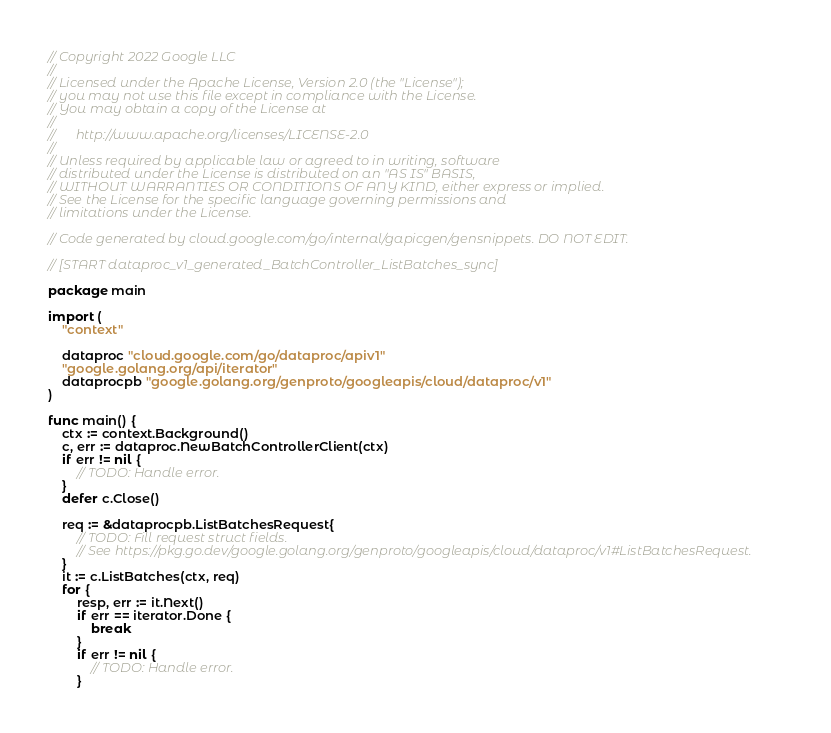<code> <loc_0><loc_0><loc_500><loc_500><_Go_>// Copyright 2022 Google LLC
//
// Licensed under the Apache License, Version 2.0 (the "License");
// you may not use this file except in compliance with the License.
// You may obtain a copy of the License at
//
//      http://www.apache.org/licenses/LICENSE-2.0
//
// Unless required by applicable law or agreed to in writing, software
// distributed under the License is distributed on an "AS IS" BASIS,
// WITHOUT WARRANTIES OR CONDITIONS OF ANY KIND, either express or implied.
// See the License for the specific language governing permissions and
// limitations under the License.

// Code generated by cloud.google.com/go/internal/gapicgen/gensnippets. DO NOT EDIT.

// [START dataproc_v1_generated_BatchController_ListBatches_sync]

package main

import (
	"context"

	dataproc "cloud.google.com/go/dataproc/apiv1"
	"google.golang.org/api/iterator"
	dataprocpb "google.golang.org/genproto/googleapis/cloud/dataproc/v1"
)

func main() {
	ctx := context.Background()
	c, err := dataproc.NewBatchControllerClient(ctx)
	if err != nil {
		// TODO: Handle error.
	}
	defer c.Close()

	req := &dataprocpb.ListBatchesRequest{
		// TODO: Fill request struct fields.
		// See https://pkg.go.dev/google.golang.org/genproto/googleapis/cloud/dataproc/v1#ListBatchesRequest.
	}
	it := c.ListBatches(ctx, req)
	for {
		resp, err := it.Next()
		if err == iterator.Done {
			break
		}
		if err != nil {
			// TODO: Handle error.
		}</code> 